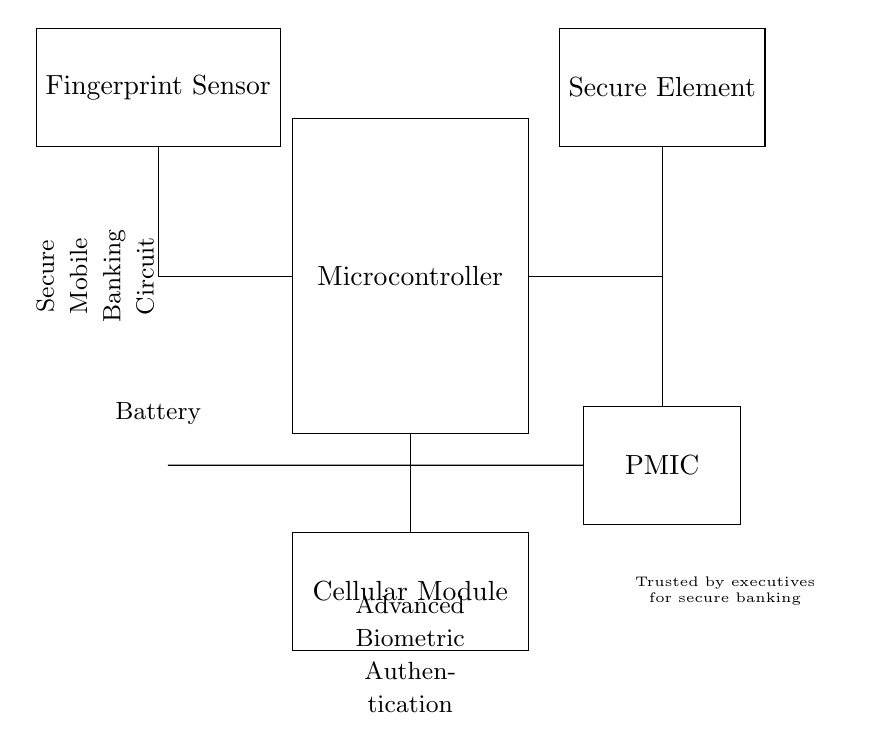What is the main component shown in the circuit? The main component in the circuit is the microcontroller, depicted as the largest rectangle at the center of the diagram. This component is crucial for managing other elements and processing data.
Answer: Microcontroller What type of sensor is included in the circuit? The circuit includes a fingerprint sensor, which is indicated in the upper left of the diagram. This sensor is responsible for reading biometric data for authentication purposes.
Answer: Fingerprint Sensor How many major components are shown in the circuit? The circuit features five major components: Microcontroller, Fingerprint Sensor, Secure Element, Cellular Module, and Power Management IC. Each plays a specific role in the operation of the mobile device.
Answer: Five Which component is responsible for managing power? The Power Management Integrated Circuit (PMIC) is responsible for managing power within the circuit. It ensures that the voltage and current levels are maintained appropriately for other components.
Answer: PMIC What connection is made between the microcontroller and the cellular module? The microcontroller connects to the cellular module via a direct downward connection. This signifies that the microcontroller is sending data to the cellular module, enabling communication features in the mobile banking application.
Answer: Direct connection What does the label on the circuit indicate about its purpose? The label indicates that this circuit is designed for "Secure Mobile Banking," which implies its primary application is to enhance security when carrying out banking transactions on mobile devices.
Answer: Secure Mobile Banking What brand endorsement is noted in the diagram? The endorsement states that the circuit is "Trusted by executives for secure banking." This label signifies that the circuit is designed to meet high standards of security, appealing to business professionals.
Answer: Trusted by executives 